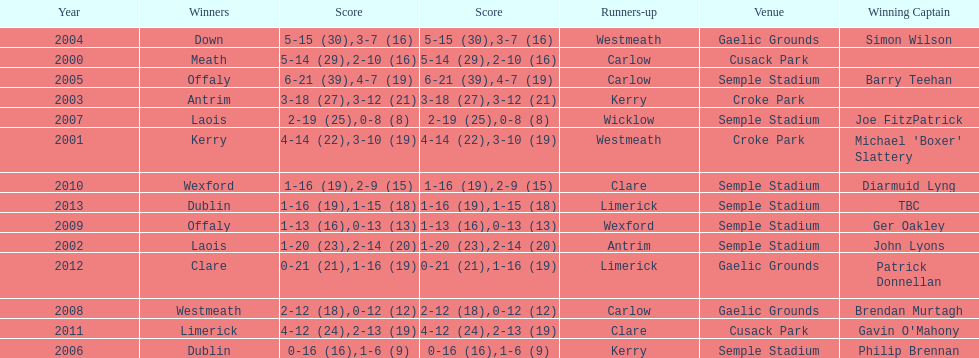How many times was carlow the runner-up? 3. 